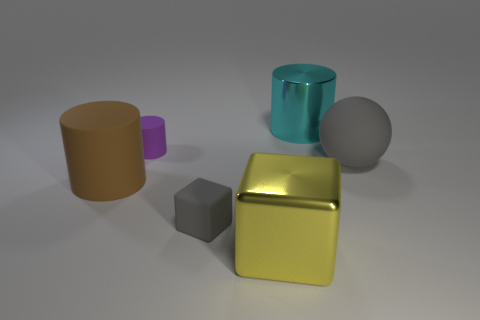Add 2 purple objects. How many objects exist? 8 Subtract all balls. How many objects are left? 5 Add 5 yellow metallic objects. How many yellow metallic objects exist? 6 Subtract 0 cyan spheres. How many objects are left? 6 Subtract all brown things. Subtract all large metallic cubes. How many objects are left? 4 Add 6 big cyan cylinders. How many big cyan cylinders are left? 7 